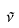Convert formula to latex. <formula><loc_0><loc_0><loc_500><loc_500>\tilde { \nu }</formula> 